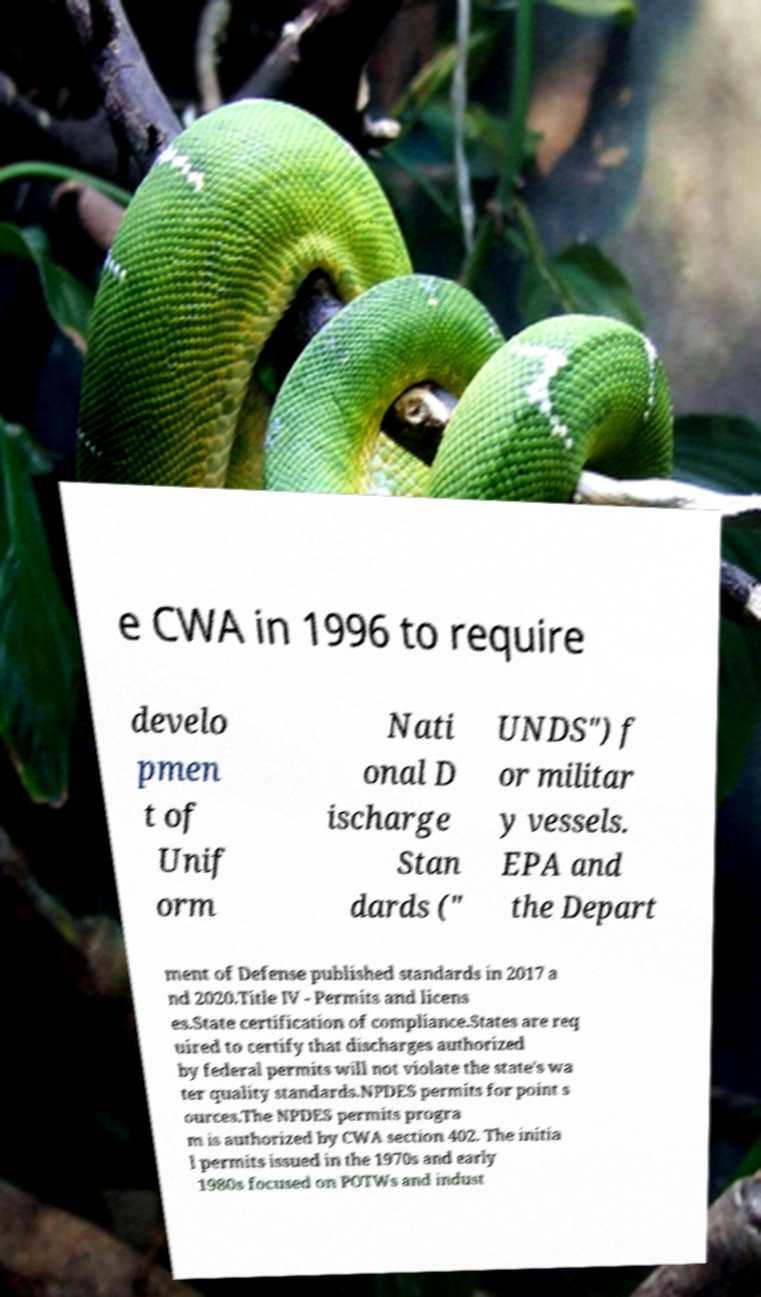Please read and relay the text visible in this image. What does it say? e CWA in 1996 to require develo pmen t of Unif orm Nati onal D ischarge Stan dards (" UNDS") f or militar y vessels. EPA and the Depart ment of Defense published standards in 2017 a nd 2020.Title IV - Permits and licens es.State certification of compliance.States are req uired to certify that discharges authorized by federal permits will not violate the state's wa ter quality standards.NPDES permits for point s ources.The NPDES permits progra m is authorized by CWA section 402. The initia l permits issued in the 1970s and early 1980s focused on POTWs and indust 